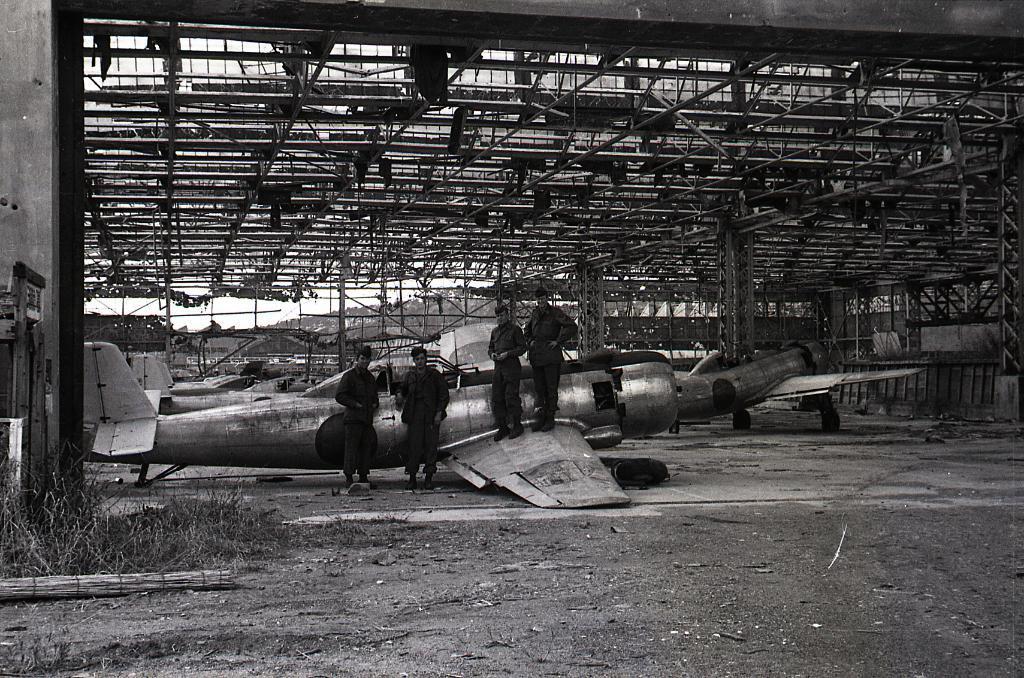How would you summarize this image in a sentence or two? This is a black and white image. At the bottom of the image on the ground there is grass. And also there are few plans on the ground. And also there are four persons standing. At the top of the image there is ceiling with rods and also there are pillars in the image. 